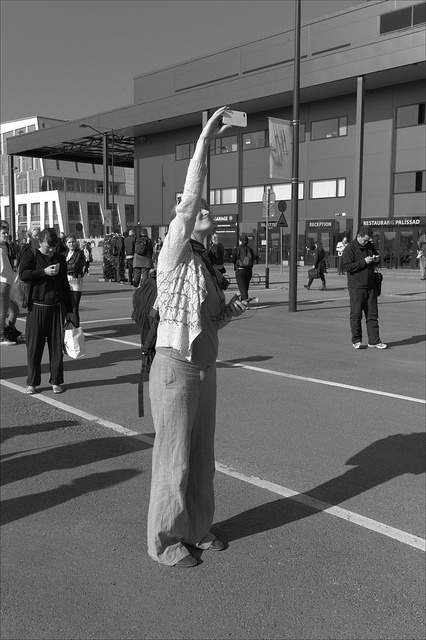Describe the objects in this image and their specific colors. I can see people in gray, black, darkgray, and lightgray tones, people in gray, black, darkgray, and lightgray tones, people in gray, black, darkgray, and lightgray tones, people in gray, black, darkgray, and lightgray tones, and backpack in gray, black, darkgray, and lightgray tones in this image. 